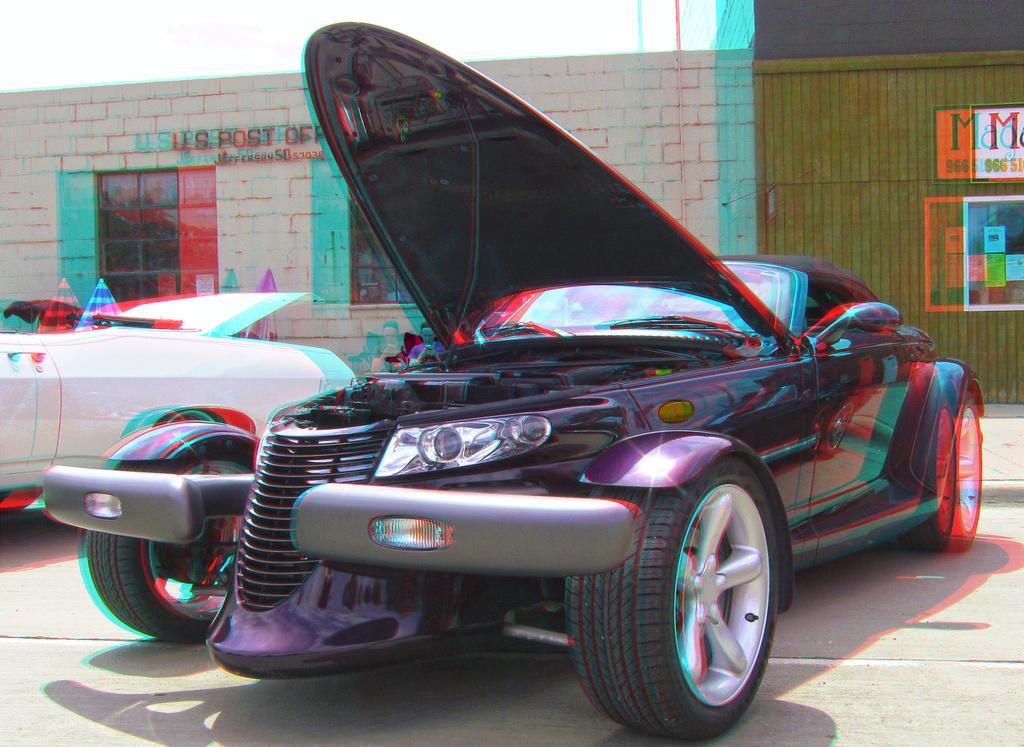What type of vehicles are on the ground in the image? There are cars on the ground in the image. What objects are present to provide shade or protection from the rain? There are umbrellas in the image. What can be seen through the windows in the image? The contents of the rooms or the view outside are visible through the windows in the image. What type of decorations are on the wall in the image? There are posters on the wall in the image. What is visible in the background of the image? The sky is visible in the background of the image. How many fingers can be seen on the goose in the image? There is no goose present in the image, and therefore no fingers can be seen on a goose. What type of furniture is visible in the image? There is no desk or any other furniture visible in the image. 